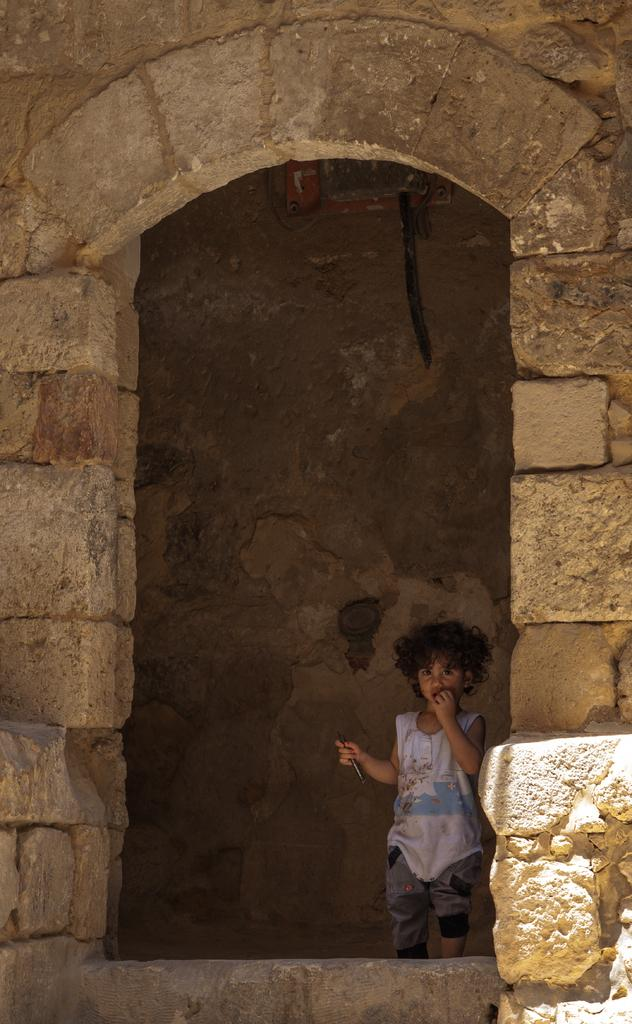What is the main subject of the image? The main subject of the image is a boy. What is the boy doing in the image? The boy is standing in the image. What is the boy holding in the image? The boy is holding an object in the image. What can be seen on the wall in the image? There is an object on the wall in the image. What type of door can be seen in the image? There is no door present in the image. What type of farm animals can be seen in the image? There is no farm or animals present in the image. What is the boy using to support his elbow in the image? The boy is not using his elbow for support in the image; he is standing with both arms at his sides. 